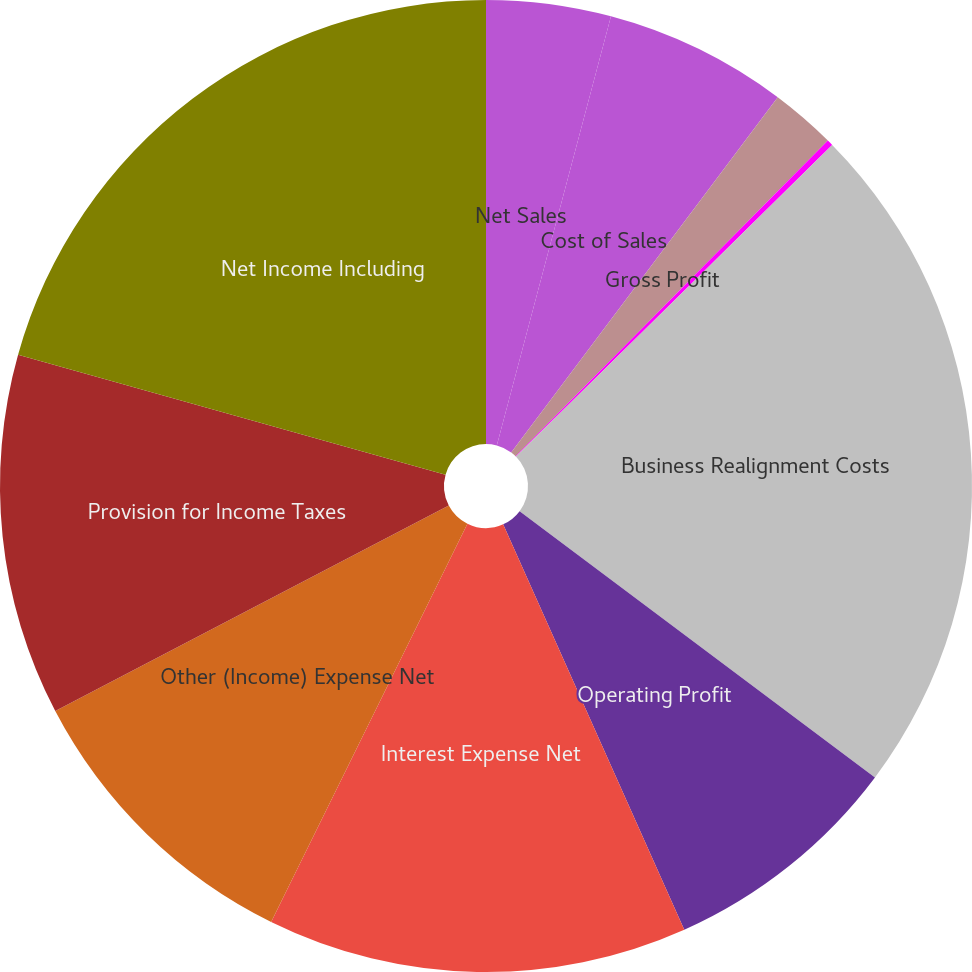<chart> <loc_0><loc_0><loc_500><loc_500><pie_chart><fcel>Net Sales<fcel>Cost of Sales<fcel>Gross Profit<fcel>SM&A Expense<fcel>Business Realignment Costs<fcel>Operating Profit<fcel>Interest Expense Net<fcel>Other (Income) Expense Net<fcel>Provision for Income Taxes<fcel>Net Income Including<nl><fcel>4.14%<fcel>6.11%<fcel>2.17%<fcel>0.2%<fcel>22.62%<fcel>8.08%<fcel>13.98%<fcel>10.05%<fcel>12.02%<fcel>20.65%<nl></chart> 